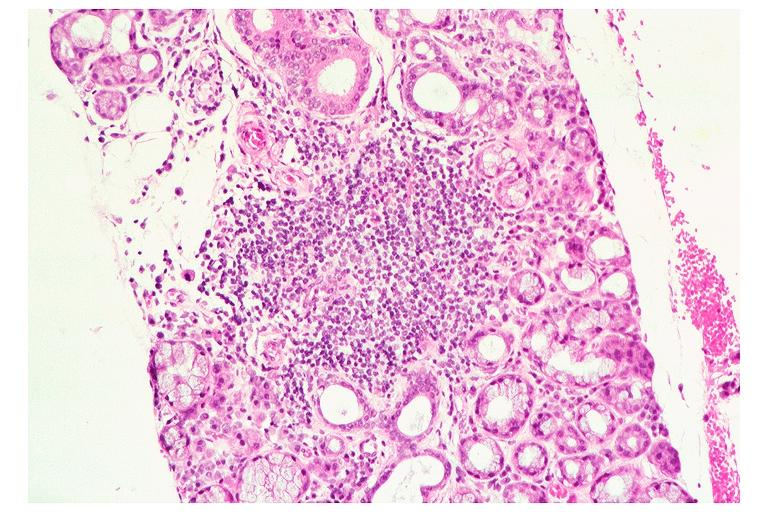where is this?
Answer the question using a single word or phrase. Oral 